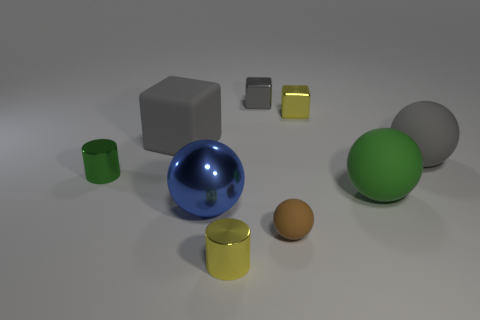What different colors are present in the objects shown? The image displays objects in various colors, including blue, green, yellow, gray, and brown. 